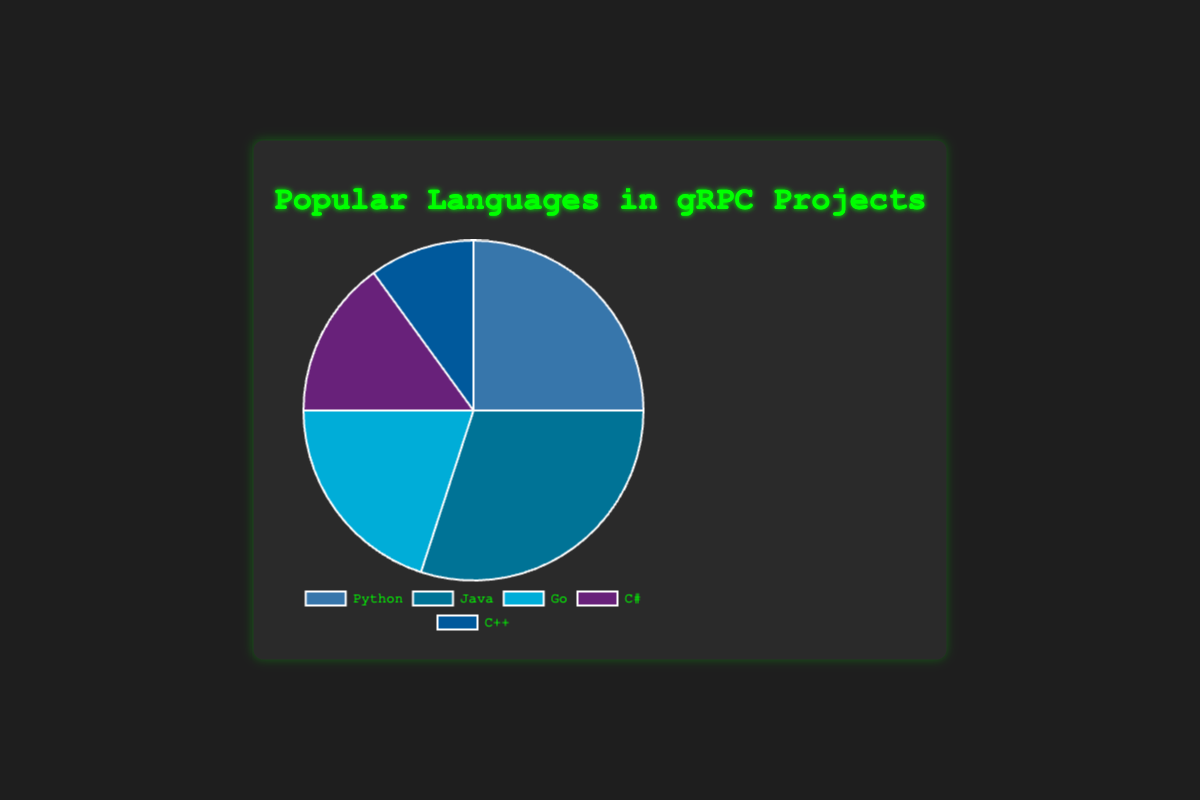What percentage of total projects use either Python or Java? To find the combined usage percentage for Python and Java, sum the individual percentages: Python (25%) + Java (30%) = 55%.
Answer: 55% Which language has the second highest usage percentage? By examining the percentages, Java has the highest usage at 30%, followed by Python at 25%, making Python the second highest.
Answer: Python How much greater is the usage percentage of Java compared to C++? Subtract the percentage of C++ from that of Java: Java (30%) - C++ (10%) = 20%.
Answer: 20% What is the average usage percentage of Go, C#, and C++ combined? First, add the percentages of Go, C#, and C++: 20% (Go) + 15% (C#) + 10% (C++) = 45%. Now, divide by the number of languages: 45% / 3 = 15%.
Answer: 15% What is the total percentage of usage for Go and C#? Add the usage percentages for Go and C#: 20% (Go) + 15% (C#) = 35%.
Answer: 35% Which language has the smallest usage percentage and what is it? By checking the usage percentages, C++ has the smallest usage at 10%.
Answer: C++, 10% What color is used to represent Java on the pie chart? Java is represented by a shade of blue in the pie chart.
Answer: Blue How does the usage percentage of Go compare to Python? The usage percentage of Go (20%) is less than that of Python (25%).
Answer: Go uses less What is the range of usage percentages across all languages? The range is calculated by subtracting the smallest percentage (C++ at 10%) from the largest percentage (Java at 30%): 30% - 10% = 20%.
Answer: 20% Which two languages, when combined, have a 45% usage percentage? Adding the usage percentages of Go (20%) and C# (15%), we get 20% + 15% = 35%. Adding Python (25%) and C++ (10%), we get 25% + 10% = 35%. Therefore, adding Python (25%) and C# (15%) we get 25% + 15% = 40%. Finally, adding Java (30%) and Go (20%) we get 30% + 20% = 50%. Therefore, Java and Go combined usage is 50%.
Answer: Go and C++ 